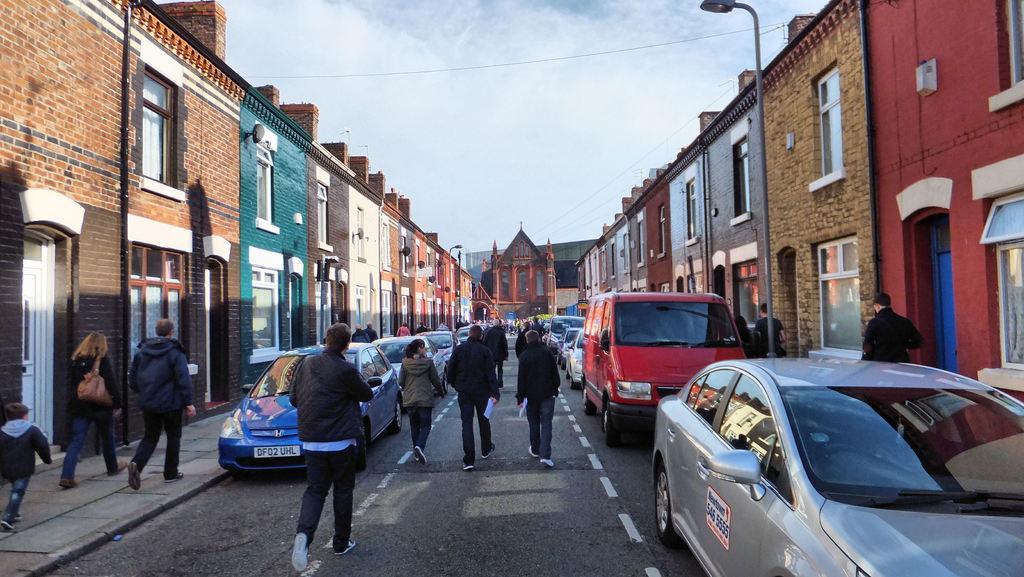Can you describe this image briefly? In this picture we can see people are walking on the road, some many vehicles are on the road, both sides of the road we can see buildings. 